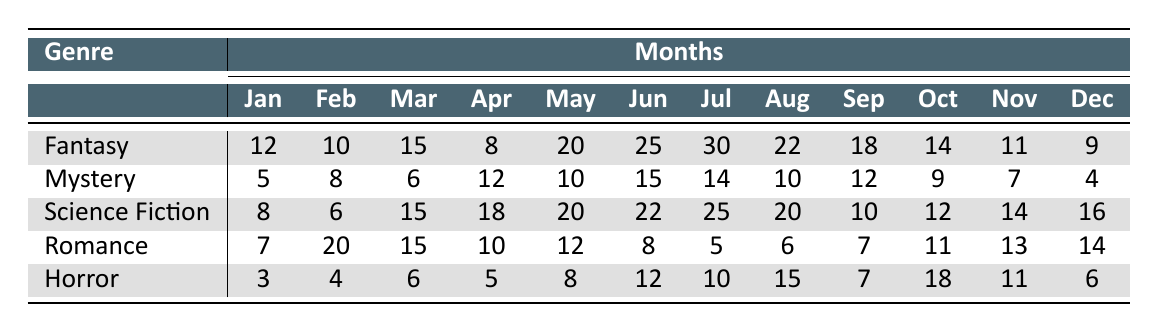What genre has the highest writing frequency in July? In July, the writing frequencies for each genre are as follows: Fantasy (30), Mystery (14), Science Fiction (25), Romance (5), and Horror (10). Comparing these values, Fantasy has the highest frequency at 30.
Answer: Fantasy What is the total writing frequency for Fantasy from January to December? The total for Fantasy can be computed by adding the monthly frequencies: 12 + 10 + 15 + 8 + 20 + 25 + 30 + 22 + 18 + 14 + 11 + 9 =  118.
Answer: 118 Which genre had the lowest writing frequency in December? In December, the frequencies are Fantasy (9), Mystery (4), Science Fiction (16), Romance (14), and Horror (6). The lowest value is from Mystery at 4.
Answer: Mystery Did Romance have a higher writing frequency in February compared to Horror? In February, Romance had a frequency of 20, while Horror had a frequency of 4. Since 20 is greater than 4, Romance did have a higher frequency.
Answer: Yes What is the average writing frequency for Mystery over the year? The frequencies for Mystery from January to December are: 5, 8, 6, 12, 10, 15, 14, 10, 12, 9, 7, 4. Adding these gives a total of 88. There are 12 months, so the average is calculated as 88/12 = 7.33.
Answer: 7.33 Which genre had a spike in writing frequency in June? June frequencies are as follows: Fantasy (25), Mystery (15), Science Fiction (22), Romance (8), and Horror (12). The greatest frequency in June is for Fantasy at 25, showing a significant spike for that month.
Answer: Fantasy What was the overall writing frequency trend for Science Fiction throughout the year? Analyzing the monthly frequencies for Science Fiction: 8, 6, 15, 18, 20, 22, 25, 20, 10, 12, 14, 16 shows a general upward and fluctuating trend peaking in July at 25, indicating varying engagement across the months.
Answer: Upward trend with fluctuations How many months did Horror exceed a writing frequency of 10? The months in which Horror exceeded 10 are June (12), July (10), August (15), and October (18), giving a total of 3 months with frequencies greater than 10.
Answer: 3 